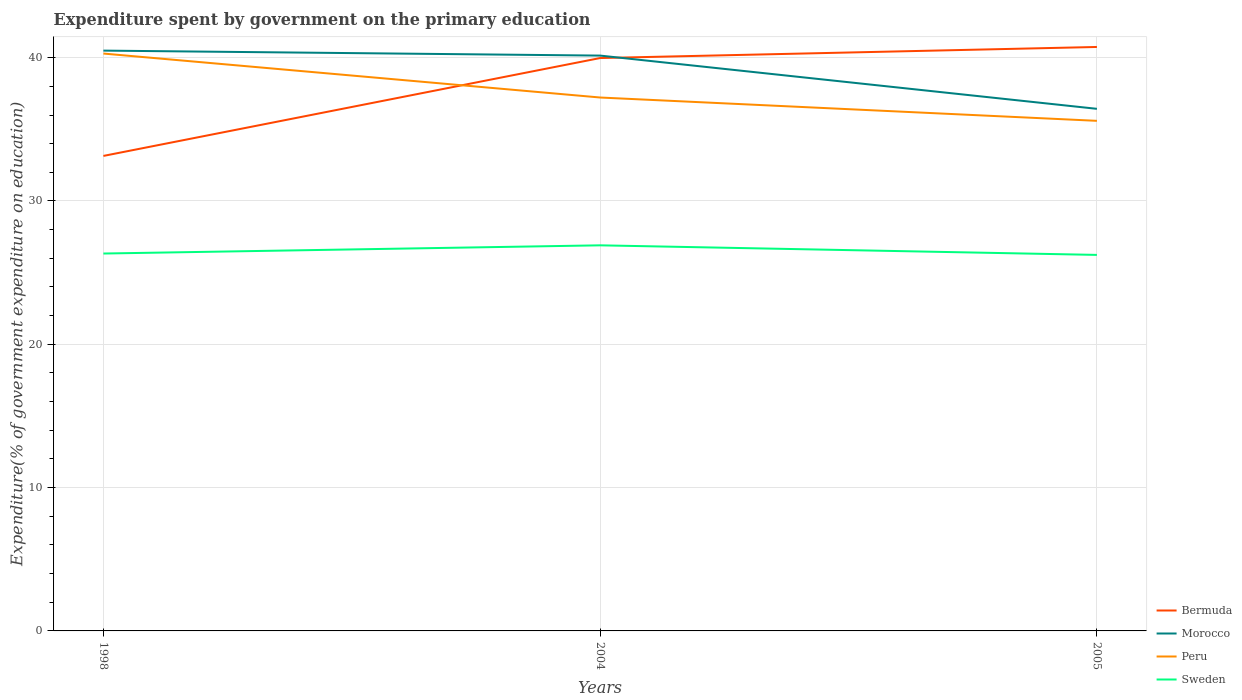Across all years, what is the maximum expenditure spent by government on the primary education in Peru?
Provide a short and direct response. 35.59. What is the total expenditure spent by government on the primary education in Morocco in the graph?
Offer a very short reply. 3.71. What is the difference between the highest and the second highest expenditure spent by government on the primary education in Morocco?
Your response must be concise. 4.06. Is the expenditure spent by government on the primary education in Morocco strictly greater than the expenditure spent by government on the primary education in Sweden over the years?
Ensure brevity in your answer.  No. How many years are there in the graph?
Make the answer very short. 3. Are the values on the major ticks of Y-axis written in scientific E-notation?
Your answer should be very brief. No. Does the graph contain any zero values?
Keep it short and to the point. No. Does the graph contain grids?
Your answer should be compact. Yes. Where does the legend appear in the graph?
Make the answer very short. Bottom right. How many legend labels are there?
Keep it short and to the point. 4. What is the title of the graph?
Your answer should be compact. Expenditure spent by government on the primary education. What is the label or title of the X-axis?
Offer a terse response. Years. What is the label or title of the Y-axis?
Your answer should be very brief. Expenditure(% of government expenditure on education). What is the Expenditure(% of government expenditure on education) of Bermuda in 1998?
Your response must be concise. 33.14. What is the Expenditure(% of government expenditure on education) in Morocco in 1998?
Give a very brief answer. 40.49. What is the Expenditure(% of government expenditure on education) in Peru in 1998?
Give a very brief answer. 40.29. What is the Expenditure(% of government expenditure on education) in Sweden in 1998?
Your answer should be compact. 26.33. What is the Expenditure(% of government expenditure on education) in Bermuda in 2004?
Your answer should be very brief. 39.97. What is the Expenditure(% of government expenditure on education) of Morocco in 2004?
Make the answer very short. 40.15. What is the Expenditure(% of government expenditure on education) of Peru in 2004?
Your answer should be very brief. 37.22. What is the Expenditure(% of government expenditure on education) of Sweden in 2004?
Your answer should be very brief. 26.91. What is the Expenditure(% of government expenditure on education) of Bermuda in 2005?
Provide a succinct answer. 40.75. What is the Expenditure(% of government expenditure on education) of Morocco in 2005?
Offer a very short reply. 36.43. What is the Expenditure(% of government expenditure on education) of Peru in 2005?
Your answer should be compact. 35.59. What is the Expenditure(% of government expenditure on education) in Sweden in 2005?
Your answer should be very brief. 26.24. Across all years, what is the maximum Expenditure(% of government expenditure on education) of Bermuda?
Keep it short and to the point. 40.75. Across all years, what is the maximum Expenditure(% of government expenditure on education) of Morocco?
Give a very brief answer. 40.49. Across all years, what is the maximum Expenditure(% of government expenditure on education) in Peru?
Make the answer very short. 40.29. Across all years, what is the maximum Expenditure(% of government expenditure on education) of Sweden?
Make the answer very short. 26.91. Across all years, what is the minimum Expenditure(% of government expenditure on education) in Bermuda?
Your answer should be very brief. 33.14. Across all years, what is the minimum Expenditure(% of government expenditure on education) of Morocco?
Offer a terse response. 36.43. Across all years, what is the minimum Expenditure(% of government expenditure on education) in Peru?
Your response must be concise. 35.59. Across all years, what is the minimum Expenditure(% of government expenditure on education) in Sweden?
Offer a terse response. 26.24. What is the total Expenditure(% of government expenditure on education) in Bermuda in the graph?
Your answer should be very brief. 113.87. What is the total Expenditure(% of government expenditure on education) in Morocco in the graph?
Offer a terse response. 117.07. What is the total Expenditure(% of government expenditure on education) of Peru in the graph?
Keep it short and to the point. 113.1. What is the total Expenditure(% of government expenditure on education) in Sweden in the graph?
Give a very brief answer. 79.48. What is the difference between the Expenditure(% of government expenditure on education) of Bermuda in 1998 and that in 2004?
Your answer should be compact. -6.83. What is the difference between the Expenditure(% of government expenditure on education) of Morocco in 1998 and that in 2004?
Offer a terse response. 0.35. What is the difference between the Expenditure(% of government expenditure on education) of Peru in 1998 and that in 2004?
Your response must be concise. 3.07. What is the difference between the Expenditure(% of government expenditure on education) of Sweden in 1998 and that in 2004?
Make the answer very short. -0.57. What is the difference between the Expenditure(% of government expenditure on education) in Bermuda in 1998 and that in 2005?
Ensure brevity in your answer.  -7.6. What is the difference between the Expenditure(% of government expenditure on education) of Morocco in 1998 and that in 2005?
Provide a succinct answer. 4.06. What is the difference between the Expenditure(% of government expenditure on education) in Peru in 1998 and that in 2005?
Offer a very short reply. 4.7. What is the difference between the Expenditure(% of government expenditure on education) of Sweden in 1998 and that in 2005?
Your answer should be very brief. 0.1. What is the difference between the Expenditure(% of government expenditure on education) in Bermuda in 2004 and that in 2005?
Provide a succinct answer. -0.77. What is the difference between the Expenditure(% of government expenditure on education) in Morocco in 2004 and that in 2005?
Provide a succinct answer. 3.71. What is the difference between the Expenditure(% of government expenditure on education) in Peru in 2004 and that in 2005?
Provide a short and direct response. 1.63. What is the difference between the Expenditure(% of government expenditure on education) in Sweden in 2004 and that in 2005?
Ensure brevity in your answer.  0.67. What is the difference between the Expenditure(% of government expenditure on education) in Bermuda in 1998 and the Expenditure(% of government expenditure on education) in Morocco in 2004?
Your answer should be very brief. -7. What is the difference between the Expenditure(% of government expenditure on education) of Bermuda in 1998 and the Expenditure(% of government expenditure on education) of Peru in 2004?
Your answer should be very brief. -4.08. What is the difference between the Expenditure(% of government expenditure on education) in Bermuda in 1998 and the Expenditure(% of government expenditure on education) in Sweden in 2004?
Offer a terse response. 6.24. What is the difference between the Expenditure(% of government expenditure on education) of Morocco in 1998 and the Expenditure(% of government expenditure on education) of Peru in 2004?
Your answer should be very brief. 3.27. What is the difference between the Expenditure(% of government expenditure on education) of Morocco in 1998 and the Expenditure(% of government expenditure on education) of Sweden in 2004?
Offer a terse response. 13.59. What is the difference between the Expenditure(% of government expenditure on education) of Peru in 1998 and the Expenditure(% of government expenditure on education) of Sweden in 2004?
Ensure brevity in your answer.  13.38. What is the difference between the Expenditure(% of government expenditure on education) of Bermuda in 1998 and the Expenditure(% of government expenditure on education) of Morocco in 2005?
Provide a succinct answer. -3.29. What is the difference between the Expenditure(% of government expenditure on education) of Bermuda in 1998 and the Expenditure(% of government expenditure on education) of Peru in 2005?
Provide a succinct answer. -2.45. What is the difference between the Expenditure(% of government expenditure on education) in Bermuda in 1998 and the Expenditure(% of government expenditure on education) in Sweden in 2005?
Give a very brief answer. 6.91. What is the difference between the Expenditure(% of government expenditure on education) in Morocco in 1998 and the Expenditure(% of government expenditure on education) in Peru in 2005?
Give a very brief answer. 4.9. What is the difference between the Expenditure(% of government expenditure on education) in Morocco in 1998 and the Expenditure(% of government expenditure on education) in Sweden in 2005?
Provide a succinct answer. 14.26. What is the difference between the Expenditure(% of government expenditure on education) in Peru in 1998 and the Expenditure(% of government expenditure on education) in Sweden in 2005?
Provide a short and direct response. 14.05. What is the difference between the Expenditure(% of government expenditure on education) in Bermuda in 2004 and the Expenditure(% of government expenditure on education) in Morocco in 2005?
Give a very brief answer. 3.54. What is the difference between the Expenditure(% of government expenditure on education) of Bermuda in 2004 and the Expenditure(% of government expenditure on education) of Peru in 2005?
Provide a succinct answer. 4.38. What is the difference between the Expenditure(% of government expenditure on education) of Bermuda in 2004 and the Expenditure(% of government expenditure on education) of Sweden in 2005?
Your answer should be very brief. 13.74. What is the difference between the Expenditure(% of government expenditure on education) of Morocco in 2004 and the Expenditure(% of government expenditure on education) of Peru in 2005?
Ensure brevity in your answer.  4.55. What is the difference between the Expenditure(% of government expenditure on education) of Morocco in 2004 and the Expenditure(% of government expenditure on education) of Sweden in 2005?
Your answer should be very brief. 13.91. What is the difference between the Expenditure(% of government expenditure on education) of Peru in 2004 and the Expenditure(% of government expenditure on education) of Sweden in 2005?
Ensure brevity in your answer.  10.98. What is the average Expenditure(% of government expenditure on education) of Bermuda per year?
Ensure brevity in your answer.  37.96. What is the average Expenditure(% of government expenditure on education) in Morocco per year?
Make the answer very short. 39.02. What is the average Expenditure(% of government expenditure on education) of Peru per year?
Your answer should be very brief. 37.7. What is the average Expenditure(% of government expenditure on education) in Sweden per year?
Make the answer very short. 26.49. In the year 1998, what is the difference between the Expenditure(% of government expenditure on education) in Bermuda and Expenditure(% of government expenditure on education) in Morocco?
Make the answer very short. -7.35. In the year 1998, what is the difference between the Expenditure(% of government expenditure on education) in Bermuda and Expenditure(% of government expenditure on education) in Peru?
Offer a very short reply. -7.14. In the year 1998, what is the difference between the Expenditure(% of government expenditure on education) of Bermuda and Expenditure(% of government expenditure on education) of Sweden?
Provide a succinct answer. 6.81. In the year 1998, what is the difference between the Expenditure(% of government expenditure on education) in Morocco and Expenditure(% of government expenditure on education) in Peru?
Your answer should be very brief. 0.21. In the year 1998, what is the difference between the Expenditure(% of government expenditure on education) of Morocco and Expenditure(% of government expenditure on education) of Sweden?
Your response must be concise. 14.16. In the year 1998, what is the difference between the Expenditure(% of government expenditure on education) in Peru and Expenditure(% of government expenditure on education) in Sweden?
Your answer should be compact. 13.95. In the year 2004, what is the difference between the Expenditure(% of government expenditure on education) of Bermuda and Expenditure(% of government expenditure on education) of Morocco?
Your answer should be very brief. -0.17. In the year 2004, what is the difference between the Expenditure(% of government expenditure on education) of Bermuda and Expenditure(% of government expenditure on education) of Peru?
Offer a very short reply. 2.75. In the year 2004, what is the difference between the Expenditure(% of government expenditure on education) of Bermuda and Expenditure(% of government expenditure on education) of Sweden?
Keep it short and to the point. 13.07. In the year 2004, what is the difference between the Expenditure(% of government expenditure on education) of Morocco and Expenditure(% of government expenditure on education) of Peru?
Make the answer very short. 2.93. In the year 2004, what is the difference between the Expenditure(% of government expenditure on education) in Morocco and Expenditure(% of government expenditure on education) in Sweden?
Your answer should be compact. 13.24. In the year 2004, what is the difference between the Expenditure(% of government expenditure on education) of Peru and Expenditure(% of government expenditure on education) of Sweden?
Offer a terse response. 10.31. In the year 2005, what is the difference between the Expenditure(% of government expenditure on education) of Bermuda and Expenditure(% of government expenditure on education) of Morocco?
Your answer should be very brief. 4.32. In the year 2005, what is the difference between the Expenditure(% of government expenditure on education) of Bermuda and Expenditure(% of government expenditure on education) of Peru?
Ensure brevity in your answer.  5.15. In the year 2005, what is the difference between the Expenditure(% of government expenditure on education) in Bermuda and Expenditure(% of government expenditure on education) in Sweden?
Your response must be concise. 14.51. In the year 2005, what is the difference between the Expenditure(% of government expenditure on education) of Morocco and Expenditure(% of government expenditure on education) of Peru?
Ensure brevity in your answer.  0.84. In the year 2005, what is the difference between the Expenditure(% of government expenditure on education) of Morocco and Expenditure(% of government expenditure on education) of Sweden?
Ensure brevity in your answer.  10.19. In the year 2005, what is the difference between the Expenditure(% of government expenditure on education) of Peru and Expenditure(% of government expenditure on education) of Sweden?
Provide a succinct answer. 9.36. What is the ratio of the Expenditure(% of government expenditure on education) of Bermuda in 1998 to that in 2004?
Your response must be concise. 0.83. What is the ratio of the Expenditure(% of government expenditure on education) of Morocco in 1998 to that in 2004?
Keep it short and to the point. 1.01. What is the ratio of the Expenditure(% of government expenditure on education) of Peru in 1998 to that in 2004?
Offer a terse response. 1.08. What is the ratio of the Expenditure(% of government expenditure on education) of Sweden in 1998 to that in 2004?
Your response must be concise. 0.98. What is the ratio of the Expenditure(% of government expenditure on education) in Bermuda in 1998 to that in 2005?
Provide a short and direct response. 0.81. What is the ratio of the Expenditure(% of government expenditure on education) in Morocco in 1998 to that in 2005?
Your answer should be compact. 1.11. What is the ratio of the Expenditure(% of government expenditure on education) in Peru in 1998 to that in 2005?
Give a very brief answer. 1.13. What is the ratio of the Expenditure(% of government expenditure on education) in Sweden in 1998 to that in 2005?
Provide a short and direct response. 1. What is the ratio of the Expenditure(% of government expenditure on education) of Morocco in 2004 to that in 2005?
Offer a very short reply. 1.1. What is the ratio of the Expenditure(% of government expenditure on education) of Peru in 2004 to that in 2005?
Ensure brevity in your answer.  1.05. What is the ratio of the Expenditure(% of government expenditure on education) in Sweden in 2004 to that in 2005?
Offer a terse response. 1.03. What is the difference between the highest and the second highest Expenditure(% of government expenditure on education) of Bermuda?
Give a very brief answer. 0.77. What is the difference between the highest and the second highest Expenditure(% of government expenditure on education) in Morocco?
Provide a succinct answer. 0.35. What is the difference between the highest and the second highest Expenditure(% of government expenditure on education) of Peru?
Offer a terse response. 3.07. What is the difference between the highest and the second highest Expenditure(% of government expenditure on education) in Sweden?
Your answer should be compact. 0.57. What is the difference between the highest and the lowest Expenditure(% of government expenditure on education) of Bermuda?
Keep it short and to the point. 7.6. What is the difference between the highest and the lowest Expenditure(% of government expenditure on education) in Morocco?
Offer a terse response. 4.06. What is the difference between the highest and the lowest Expenditure(% of government expenditure on education) in Peru?
Give a very brief answer. 4.7. What is the difference between the highest and the lowest Expenditure(% of government expenditure on education) of Sweden?
Give a very brief answer. 0.67. 